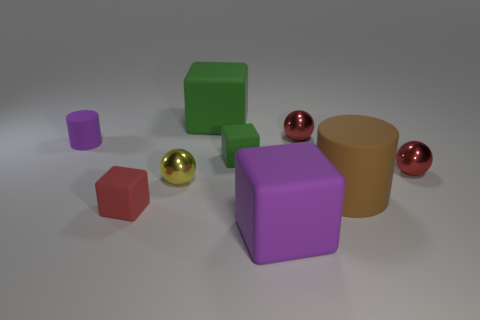Subtract 1 blocks. How many blocks are left? 3 Add 1 red blocks. How many objects exist? 10 Subtract all small red blocks. How many blocks are left? 3 Subtract all brown blocks. Subtract all brown cylinders. How many blocks are left? 4 Subtract all cylinders. How many objects are left? 7 Add 5 large gray matte cubes. How many large gray matte cubes exist? 5 Subtract 1 green cubes. How many objects are left? 8 Subtract all shiny things. Subtract all brown things. How many objects are left? 5 Add 5 tiny matte cylinders. How many tiny matte cylinders are left? 6 